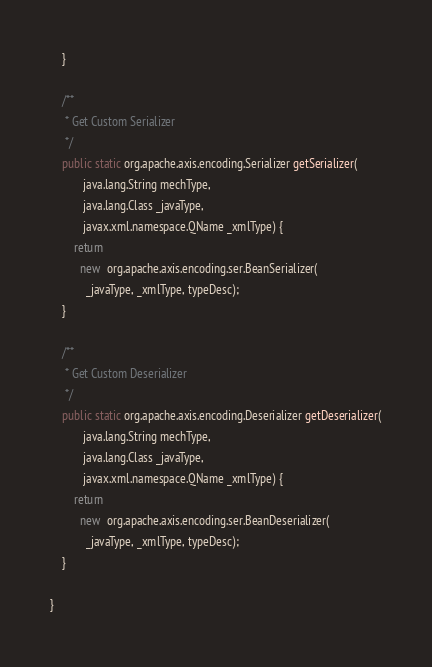<code> <loc_0><loc_0><loc_500><loc_500><_Java_>    }

    /**
     * Get Custom Serializer
     */
    public static org.apache.axis.encoding.Serializer getSerializer(
           java.lang.String mechType, 
           java.lang.Class _javaType,  
           javax.xml.namespace.QName _xmlType) {
        return 
          new  org.apache.axis.encoding.ser.BeanSerializer(
            _javaType, _xmlType, typeDesc);
    }

    /**
     * Get Custom Deserializer
     */
    public static org.apache.axis.encoding.Deserializer getDeserializer(
           java.lang.String mechType, 
           java.lang.Class _javaType,  
           javax.xml.namespace.QName _xmlType) {
        return 
          new  org.apache.axis.encoding.ser.BeanDeserializer(
            _javaType, _xmlType, typeDesc);
    }

}
</code> 